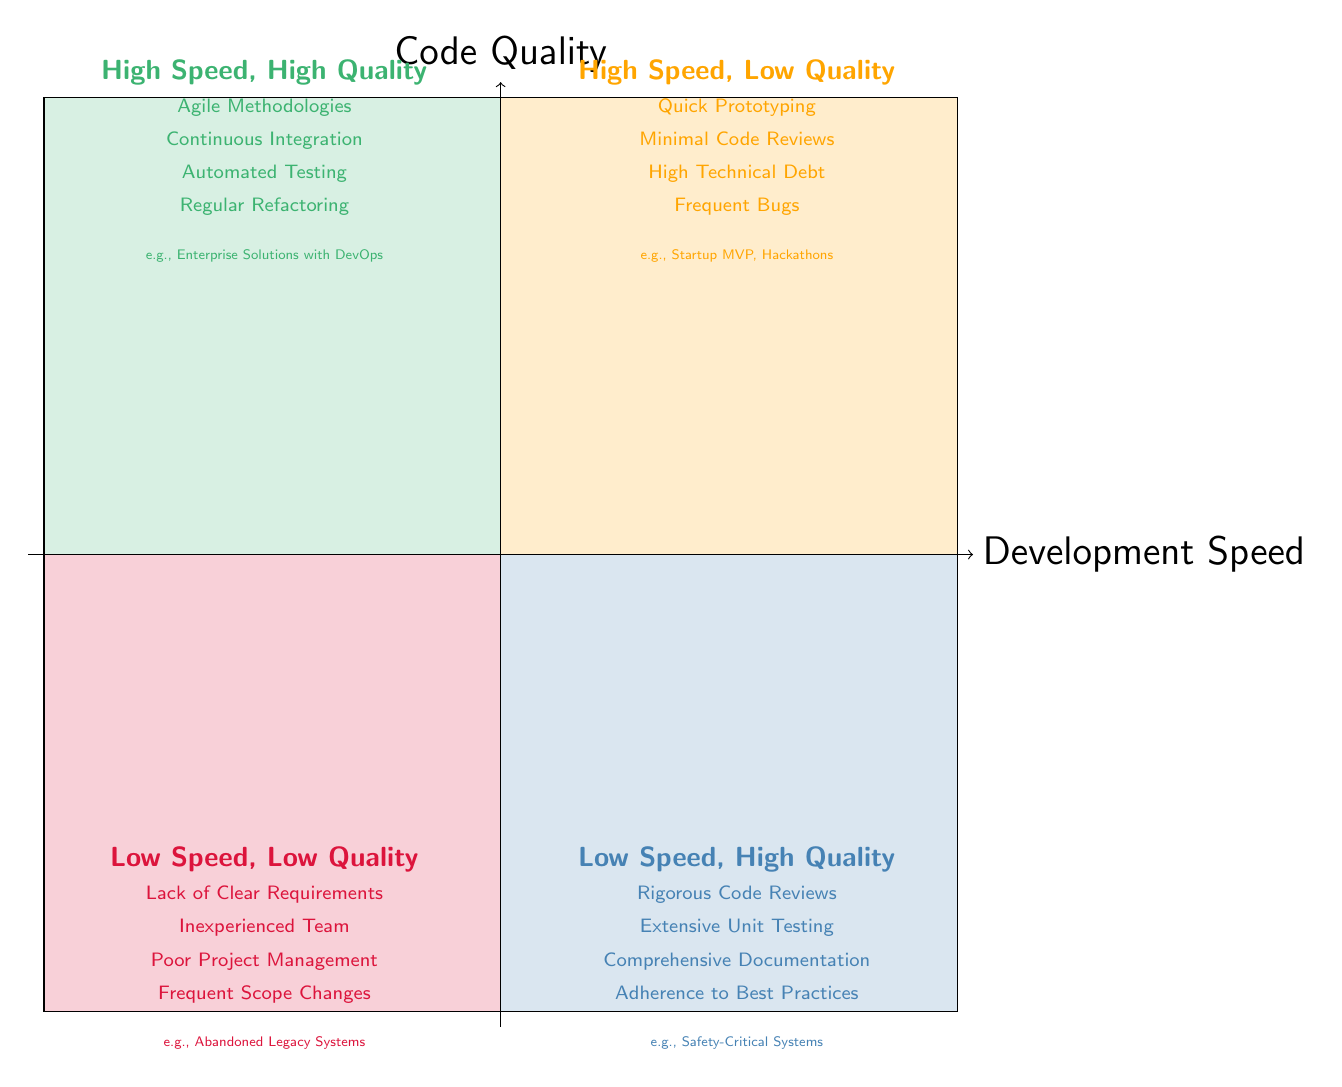What is in Quadrant 1? Quadrant 1 is in the top-right section of the chart labeled "High Development Speed, Low Code Quality." The major characteristics listed here include quick prototyping and minimal code reviews.
Answer: High Development Speed, Low Code Quality How many quadrants are represented in the chart? The chart divides the area into four distinct quadrants, each representing different levels of development speed and code quality.
Answer: Four Which quadrant corresponds to both high development speed and high code quality? The quadrant that showcases high development speed along with high code quality is Quadrant 2, which is located in the top-left section of the chart.
Answer: Quadrant 2 What examples are provided for Quadrant 4? In Quadrant 4, which indicates low development speed but high code quality, the examples listed are safety-critical systems and highly-regulated industries.
Answer: Safety-Critical Systems, Highly-Regulated Industries What are the characteristics of Quadrant 3? Quadrant 3 is characterized by a lack of clear requirements, an inexperienced team, poor project management, and frequent scope changes indicating low development speed and low code quality.
Answer: Lack of Clear Requirements, Inexperienced Team, Poor Project Management, Frequent Scope Changes Which quadrant features rigorous code reviews? Rigorous code reviews are highlighted in Quadrant 4, representing low development speed yet high code quality.
Answer: Quadrant 4 Which quadrant experiences high technical debt? High technical debt is a characteristic noted in Quadrant 1, which demonstrates high development speed and low code quality.
Answer: Quadrant 1 What is the main method mentioned in Quadrant 2? Quadrant 2 mentions the use of agile methodologies, reflecting the high development speed and high code quality achieved in that quadrant.
Answer: Agile Methodologies 